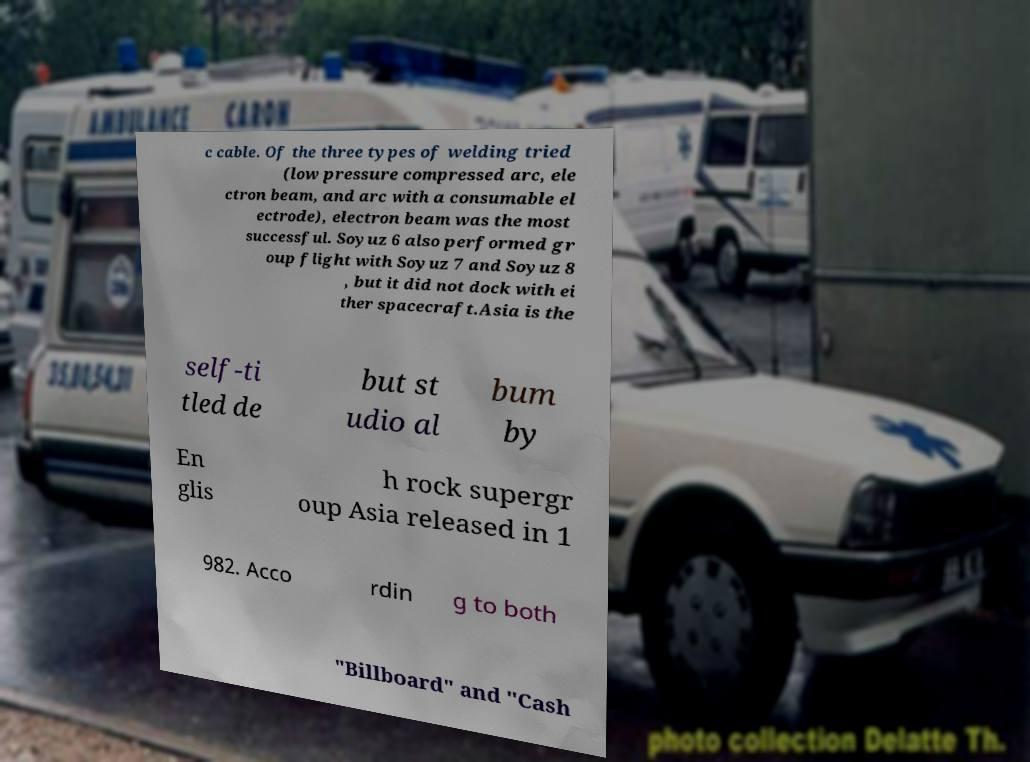Can you read and provide the text displayed in the image?This photo seems to have some interesting text. Can you extract and type it out for me? c cable. Of the three types of welding tried (low pressure compressed arc, ele ctron beam, and arc with a consumable el ectrode), electron beam was the most successful. Soyuz 6 also performed gr oup flight with Soyuz 7 and Soyuz 8 , but it did not dock with ei ther spacecraft.Asia is the self-ti tled de but st udio al bum by En glis h rock supergr oup Asia released in 1 982. Acco rdin g to both "Billboard" and "Cash 